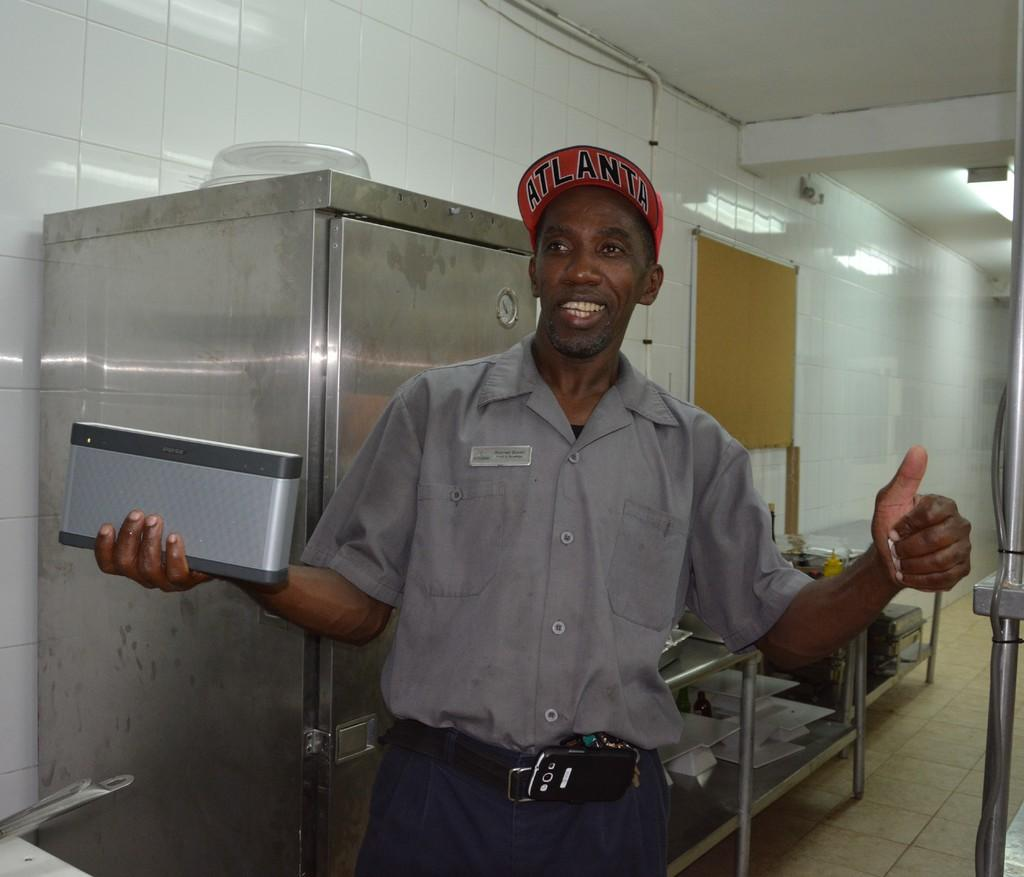Provide a one-sentence caption for the provided image. a man with a hat on that says Atlanta. 